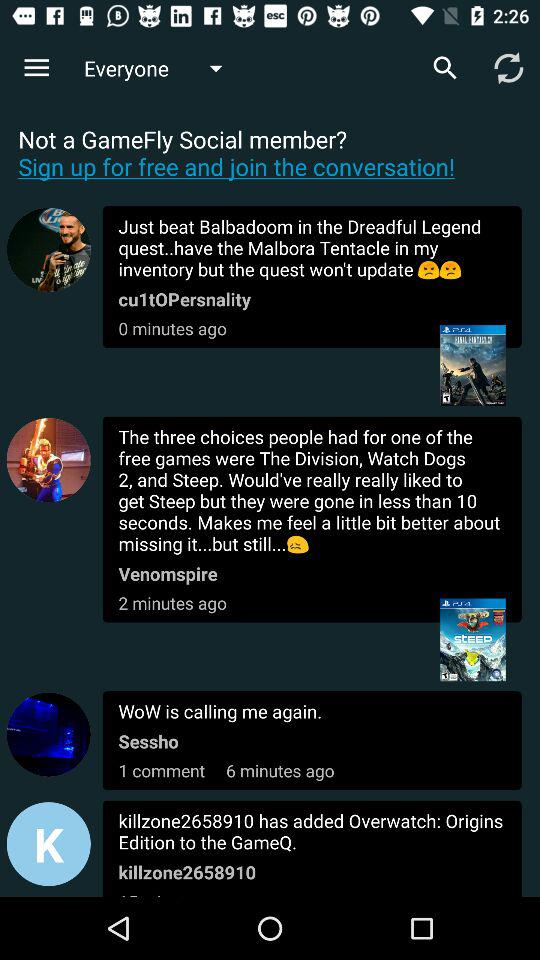What is the number of comments on the message sent by "Sessho"? The number of comments is 1. 